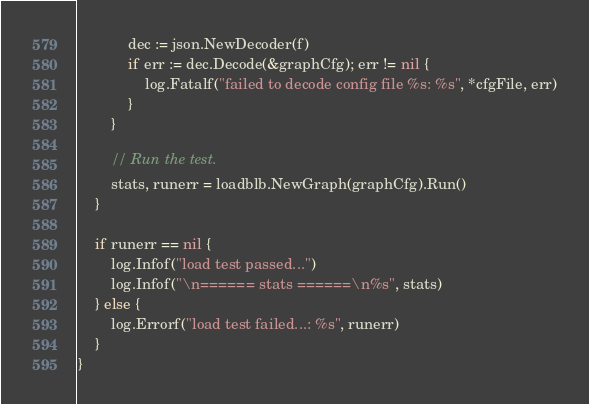Convert code to text. <code><loc_0><loc_0><loc_500><loc_500><_Go_>			dec := json.NewDecoder(f)
			if err := dec.Decode(&graphCfg); err != nil {
				log.Fatalf("failed to decode config file %s: %s", *cfgFile, err)
			}
		}

		// Run the test.
		stats, runerr = loadblb.NewGraph(graphCfg).Run()
	}

	if runerr == nil {
		log.Infof("load test passed...")
		log.Infof("\n====== stats ======\n%s", stats)
	} else {
		log.Errorf("load test failed...: %s", runerr)
	}
}
</code> 